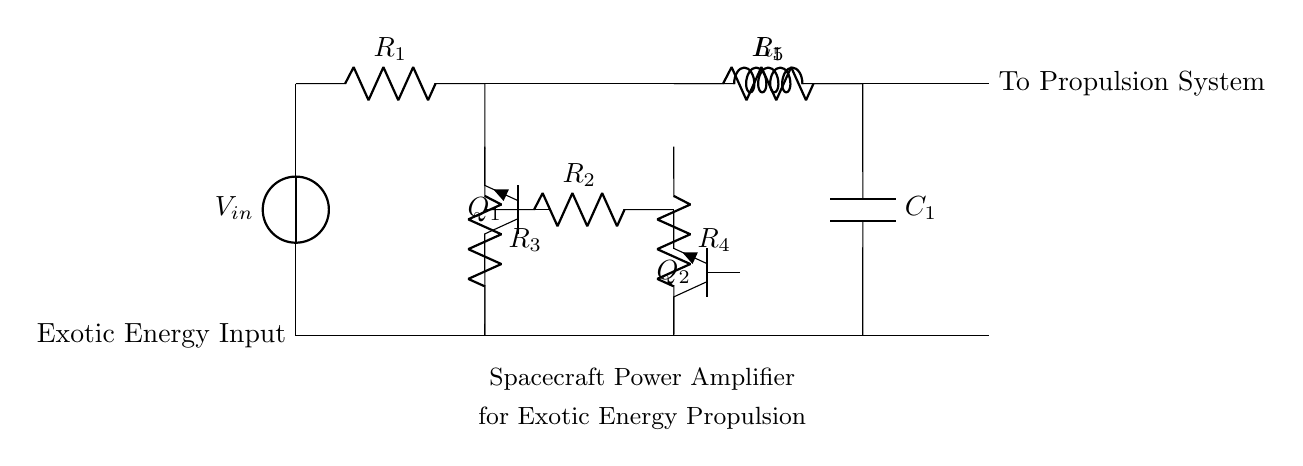What is the input voltage of the amplifier? The input voltage is labeled as V_in in the circuit diagram, indicating the potential difference supplied to the amplifier from the exotic energy source.
Answer: V_in How many resistors are present in the circuit? The circuit diagram shows four resistors labeled R_1, R_2, R_3, and R_4, which are used for biasing and stabilizing the transistors.
Answer: Four What type of transistors are used in this amplifier circuit? The transistors are labeled as Tnpn and represent NPN type transistors, which are commonly used in amplification circuits due to their current gain properties.
Answer: NPN What is connected to the output of the amplifier? The output is connected to the propulsion system, as indicated by the label "To Propulsion System" in the diagram, meaning the amplified energy will be utilized for spacecraft propulsion.
Answer: Propulsion System How does the circuit stabilize the operation of the transistors? The circuit uses resistors R_3 and R_4 for biasing the NPN transistors to ensure they operate in the correct region of their characteristics, preventing linearity loss and distortion in amplification.
Answer: Resistors What is the function of the inductor in this circuit? The inductor labeled L_1 is used for energy storage and filtering within the circuit, helping to smooth out the fluctuations in current and voltage that may arise during amplification.
Answer: Energy Storage Which component provides the delay in the signal? The capacitor labeled C_1 serves as a filter and can introduce a delay in the signal by charging and discharging, thus affecting the timing and stabilization of the amplified output.
Answer: Capacitor 